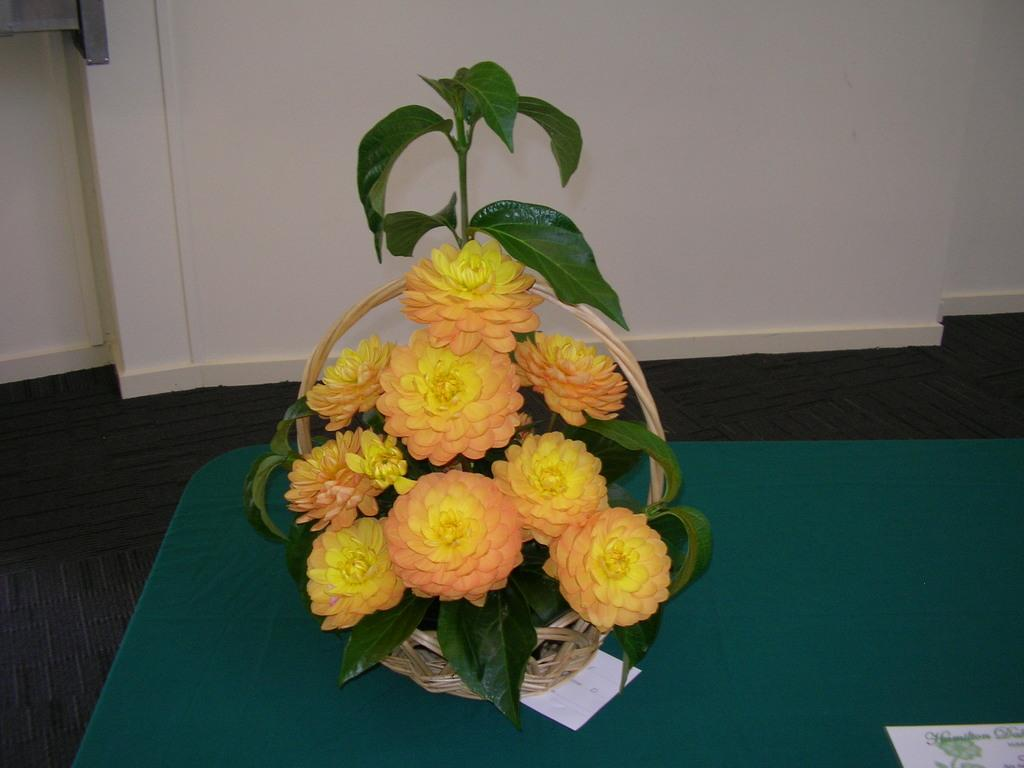What is in the basket that is visible in the image? There are flowers in a basket in the image. What is the color or material of the surface beneath the basket? The basket is on a green carpet. What architectural feature can be seen in the image? There is a door visible in the image. Where is the paper located in the image? The paper is in the bottom right corner of the image. Can you see any sea creatures swimming near the flowers in the image? There is no sea or sea creatures present in the image; it features a basket of flowers on a green carpet with a door and a paper in the bottom right corner. 